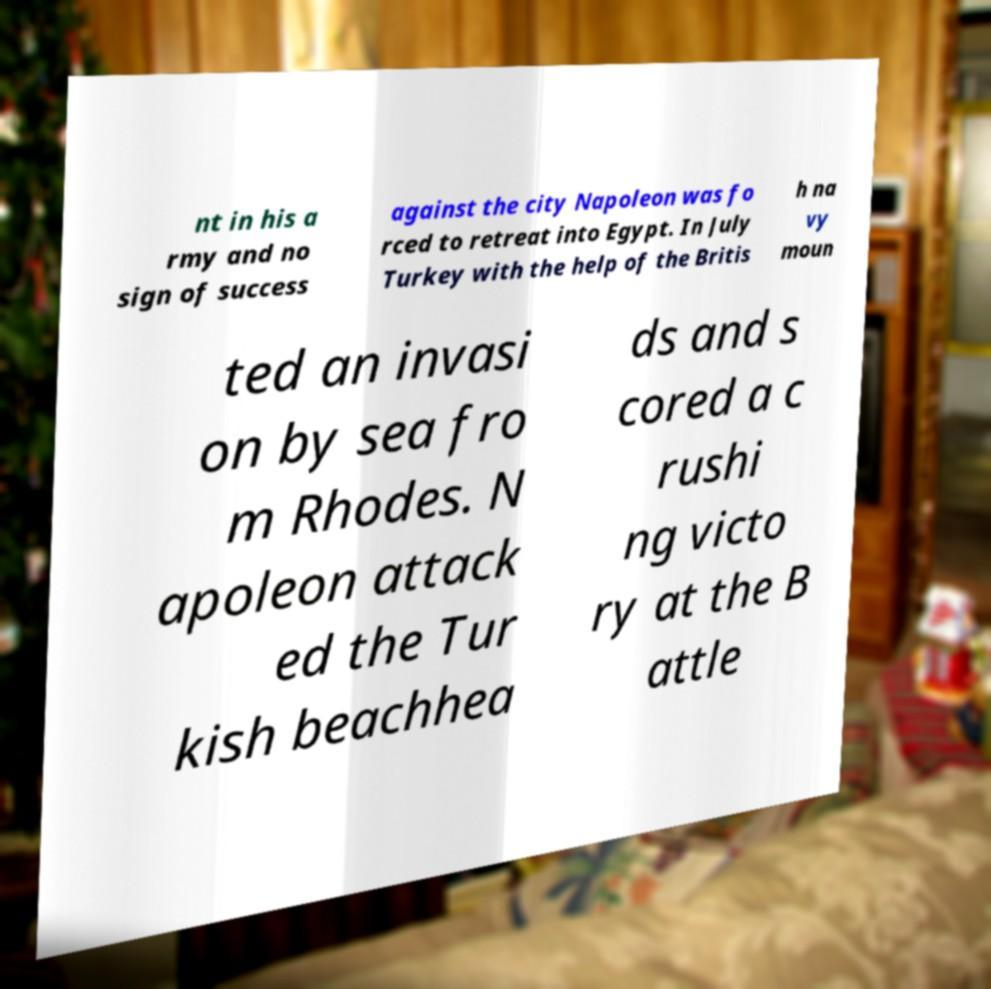What messages or text are displayed in this image? I need them in a readable, typed format. nt in his a rmy and no sign of success against the city Napoleon was fo rced to retreat into Egypt. In July Turkey with the help of the Britis h na vy moun ted an invasi on by sea fro m Rhodes. N apoleon attack ed the Tur kish beachhea ds and s cored a c rushi ng victo ry at the B attle 